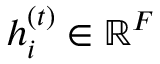Convert formula to latex. <formula><loc_0><loc_0><loc_500><loc_500>{ h } _ { i } ^ { ( t ) } \in \mathbb { R } ^ { F }</formula> 